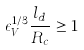<formula> <loc_0><loc_0><loc_500><loc_500>\epsilon _ { V } ^ { 1 / 3 } \frac { l _ { d } } { R _ { c } } \geq 1</formula> 